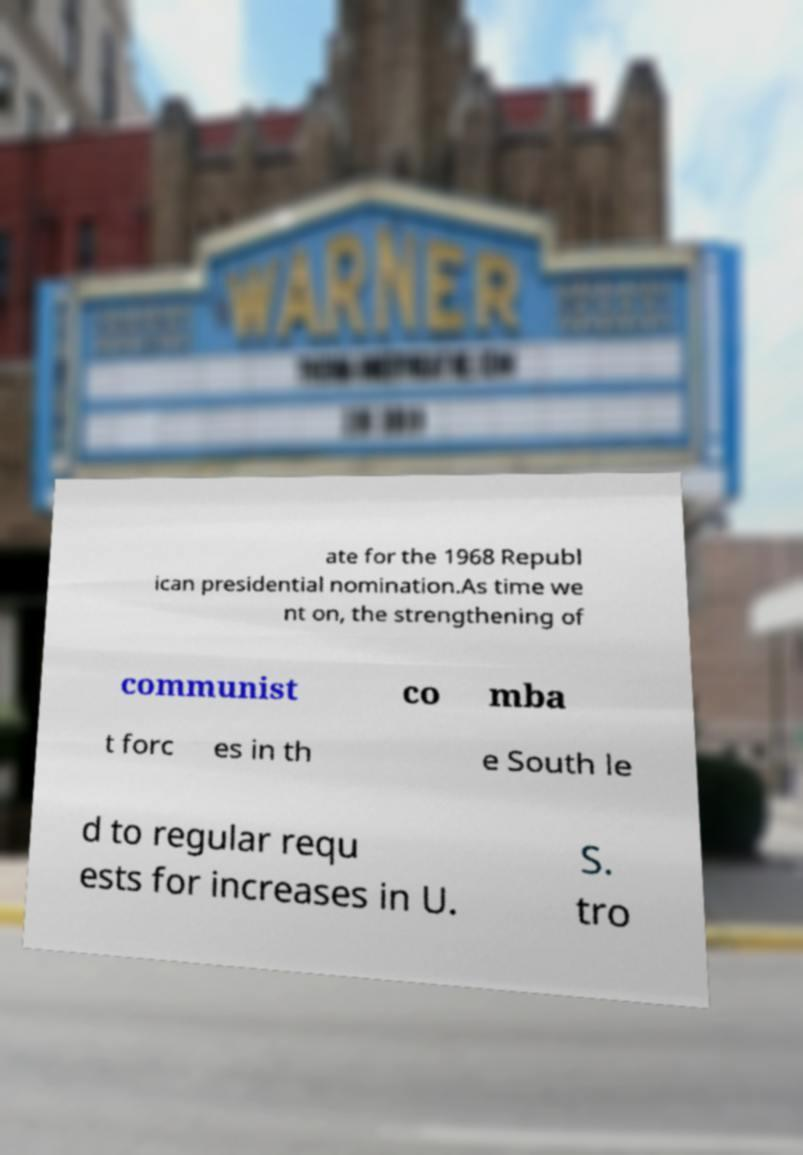For documentation purposes, I need the text within this image transcribed. Could you provide that? ate for the 1968 Republ ican presidential nomination.As time we nt on, the strengthening of communist co mba t forc es in th e South le d to regular requ ests for increases in U. S. tro 